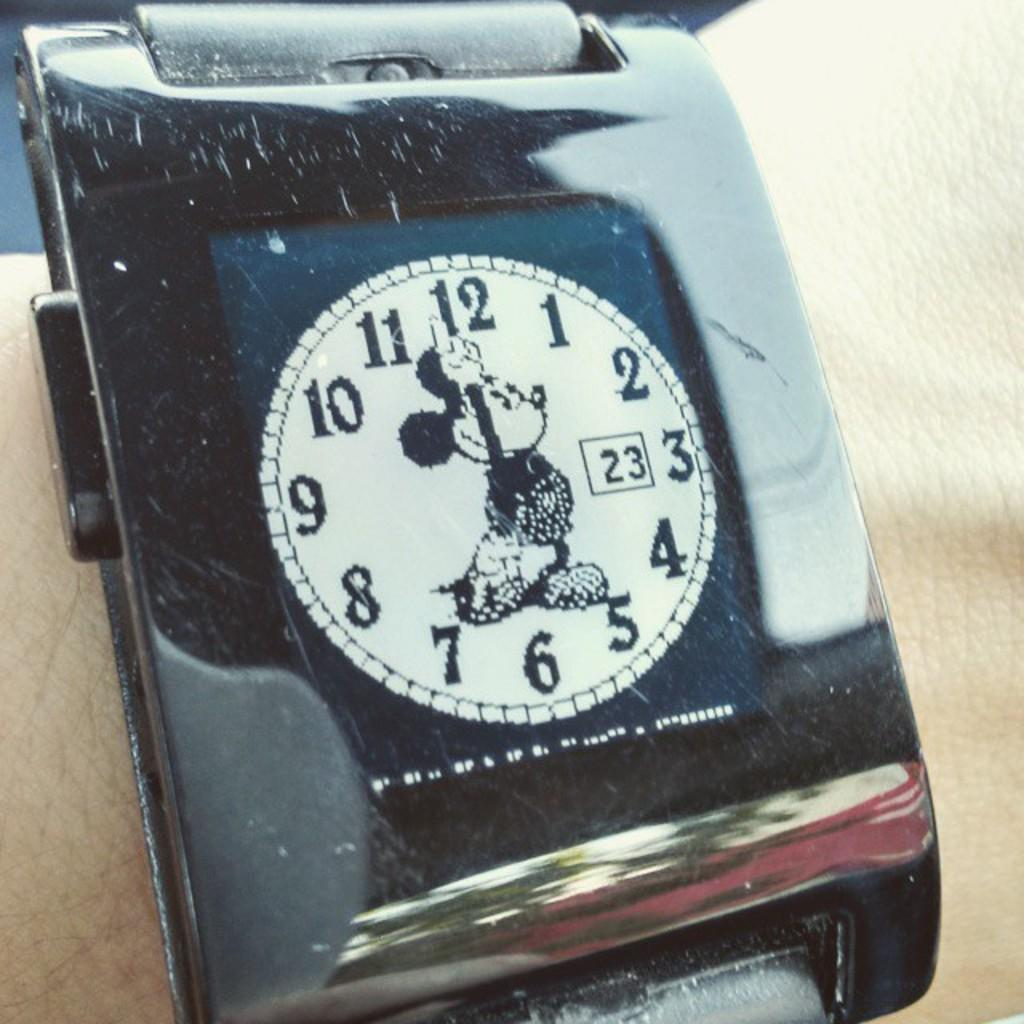<image>
Offer a succinct explanation of the picture presented. The digital Mickey Mouse watch shows the time is seven o'clock on the 23rd. 